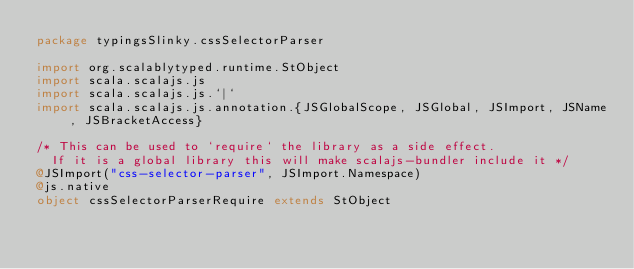Convert code to text. <code><loc_0><loc_0><loc_500><loc_500><_Scala_>package typingsSlinky.cssSelectorParser

import org.scalablytyped.runtime.StObject
import scala.scalajs.js
import scala.scalajs.js.`|`
import scala.scalajs.js.annotation.{JSGlobalScope, JSGlobal, JSImport, JSName, JSBracketAccess}

/* This can be used to `require` the library as a side effect.
  If it is a global library this will make scalajs-bundler include it */
@JSImport("css-selector-parser", JSImport.Namespace)
@js.native
object cssSelectorParserRequire extends StObject
</code> 